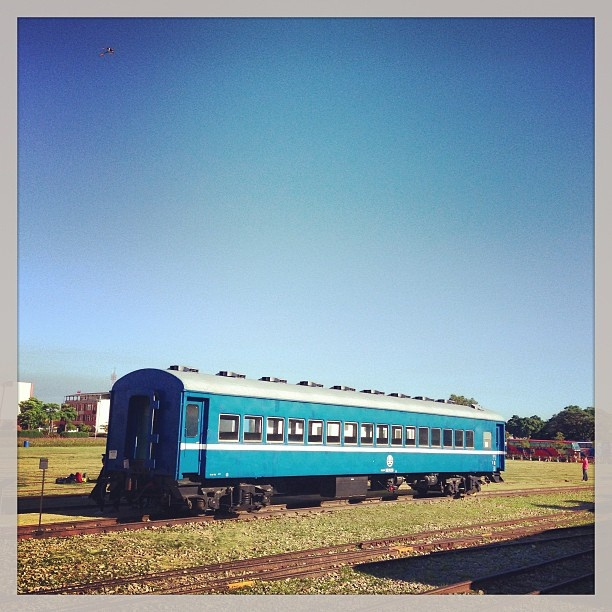Describe the objects in this image and their specific colors. I can see train in darkgray, black, ivory, teal, and navy tones and people in darkgray, maroon, lightpink, black, and gray tones in this image. 